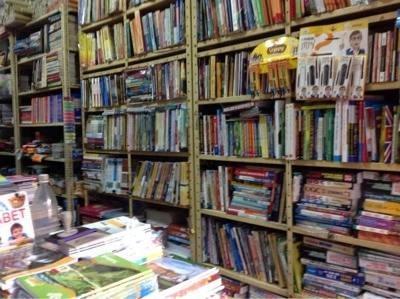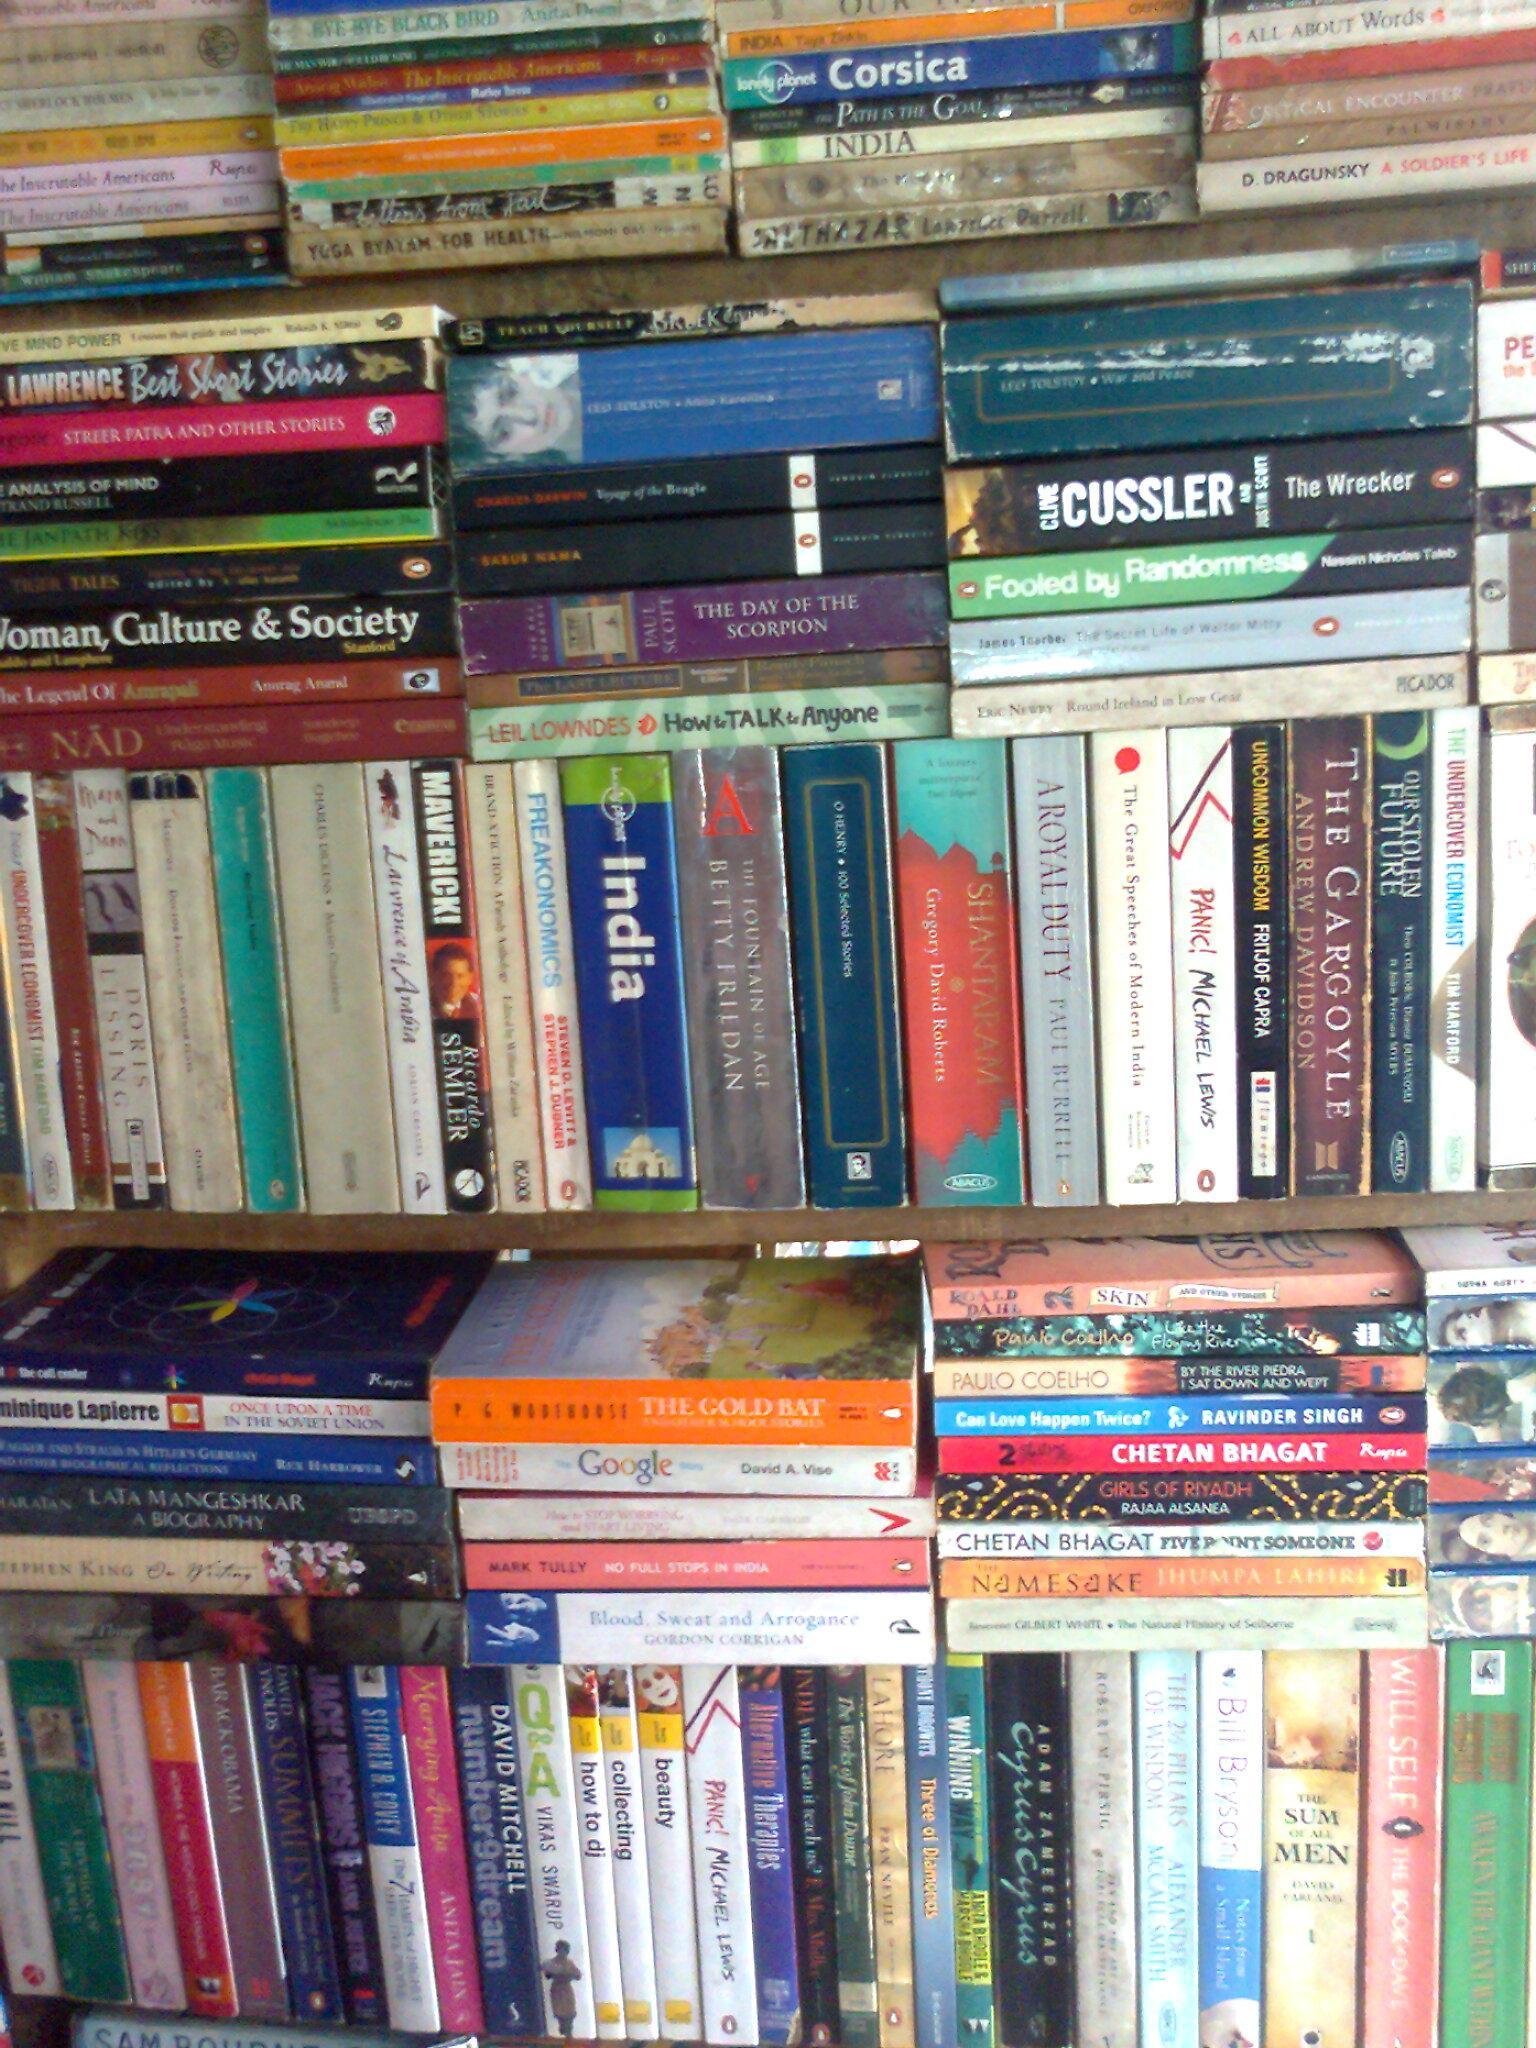The first image is the image on the left, the second image is the image on the right. Analyze the images presented: Is the assertion "All images contain books stored on book shelves." valid? Answer yes or no. Yes. 